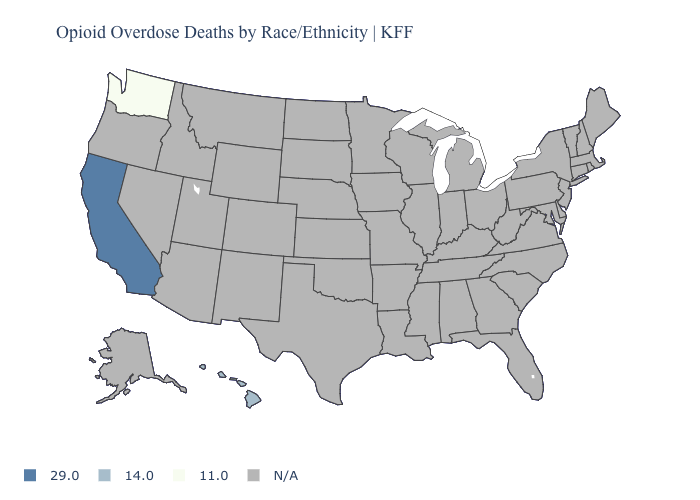Does Hawaii have the lowest value in the USA?
Concise answer only. No. What is the value of Nevada?
Concise answer only. N/A. Does Washington have the lowest value in the USA?
Give a very brief answer. Yes. Does the first symbol in the legend represent the smallest category?
Keep it brief. No. Is the legend a continuous bar?
Answer briefly. No. Name the states that have a value in the range 11.0?
Keep it brief. Washington. Name the states that have a value in the range 29.0?
Concise answer only. California. What is the value of South Dakota?
Concise answer only. N/A. Name the states that have a value in the range 29.0?
Be succinct. California. What is the value of Mississippi?
Be succinct. N/A. 